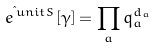Convert formula to latex. <formula><loc_0><loc_0><loc_500><loc_500>e ^ { \i u n i t S } [ \gamma ] = \prod _ { a } q _ { a } ^ { d _ { a } }</formula> 